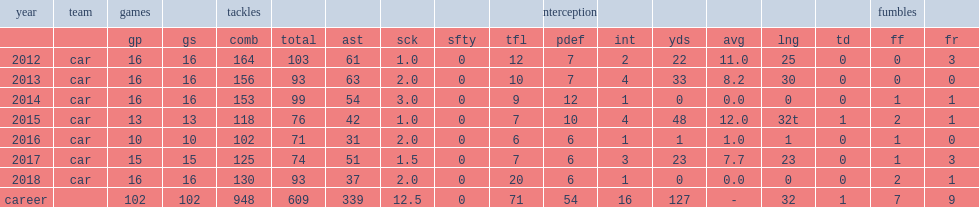In the regular 2014 season, how many tackles did kuechly make? 153. 